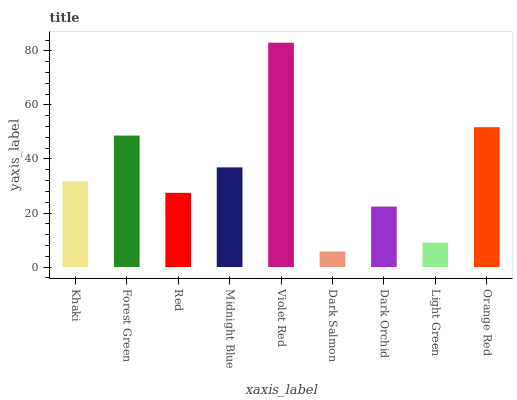Is Dark Salmon the minimum?
Answer yes or no. Yes. Is Violet Red the maximum?
Answer yes or no. Yes. Is Forest Green the minimum?
Answer yes or no. No. Is Forest Green the maximum?
Answer yes or no. No. Is Forest Green greater than Khaki?
Answer yes or no. Yes. Is Khaki less than Forest Green?
Answer yes or no. Yes. Is Khaki greater than Forest Green?
Answer yes or no. No. Is Forest Green less than Khaki?
Answer yes or no. No. Is Khaki the high median?
Answer yes or no. Yes. Is Khaki the low median?
Answer yes or no. Yes. Is Light Green the high median?
Answer yes or no. No. Is Violet Red the low median?
Answer yes or no. No. 